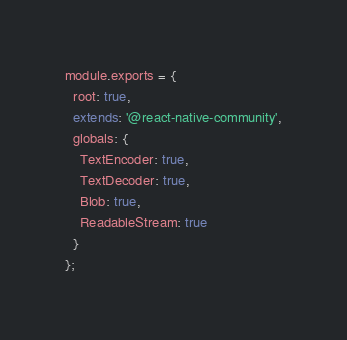Convert code to text. <code><loc_0><loc_0><loc_500><loc_500><_JavaScript_>module.exports = {
  root: true,
  extends: '@react-native-community',
  globals: {
    TextEncoder: true,
    TextDecoder: true,
    Blob: true,
    ReadableStream: true
  }
};
</code> 